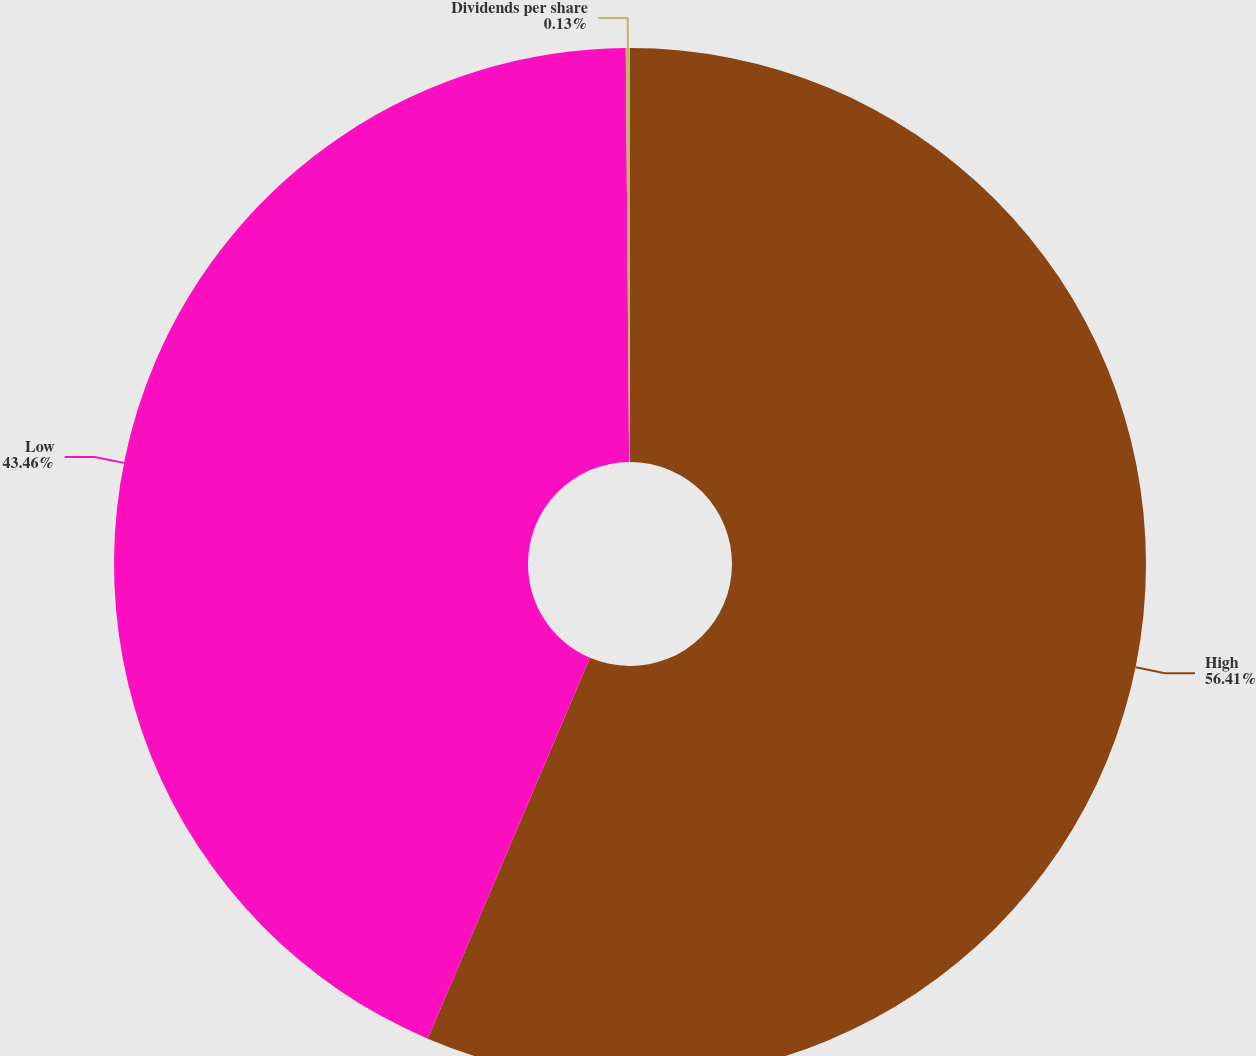<chart> <loc_0><loc_0><loc_500><loc_500><pie_chart><fcel>High<fcel>Low<fcel>Dividends per share<nl><fcel>56.41%<fcel>43.46%<fcel>0.13%<nl></chart> 